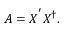<formula> <loc_0><loc_0><loc_500><loc_500>A = X ^ { ^ { \prime } } X ^ { \dag } .</formula> 